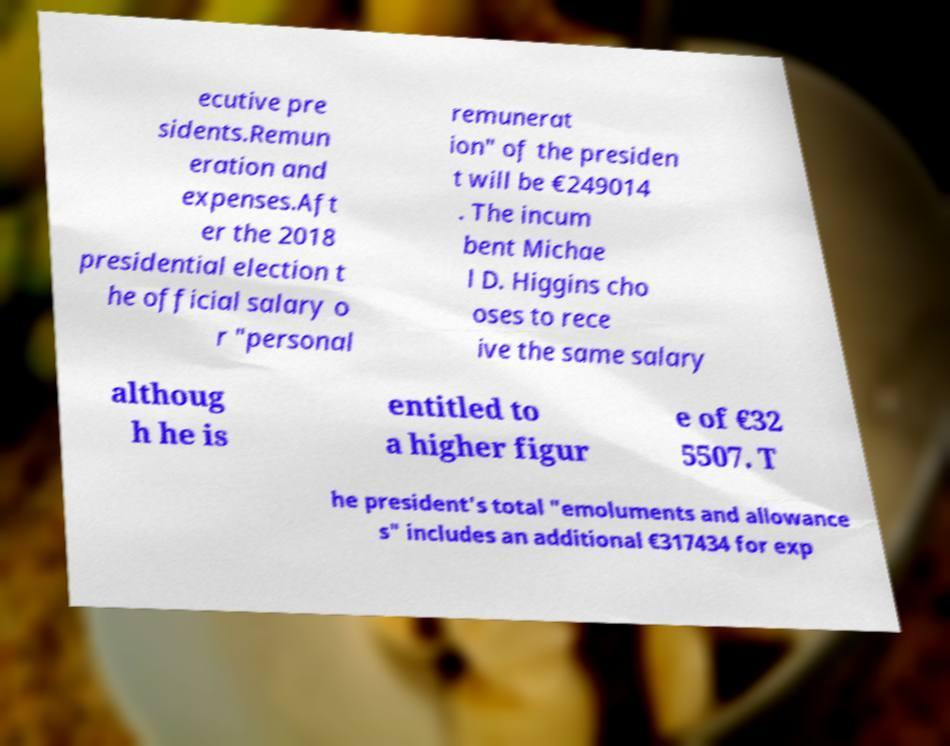Please read and relay the text visible in this image. What does it say? ecutive pre sidents.Remun eration and expenses.Aft er the 2018 presidential election t he official salary o r "personal remunerat ion" of the presiden t will be €249014 . The incum bent Michae l D. Higgins cho oses to rece ive the same salary althoug h he is entitled to a higher figur e of €32 5507. T he president's total "emoluments and allowance s" includes an additional €317434 for exp 